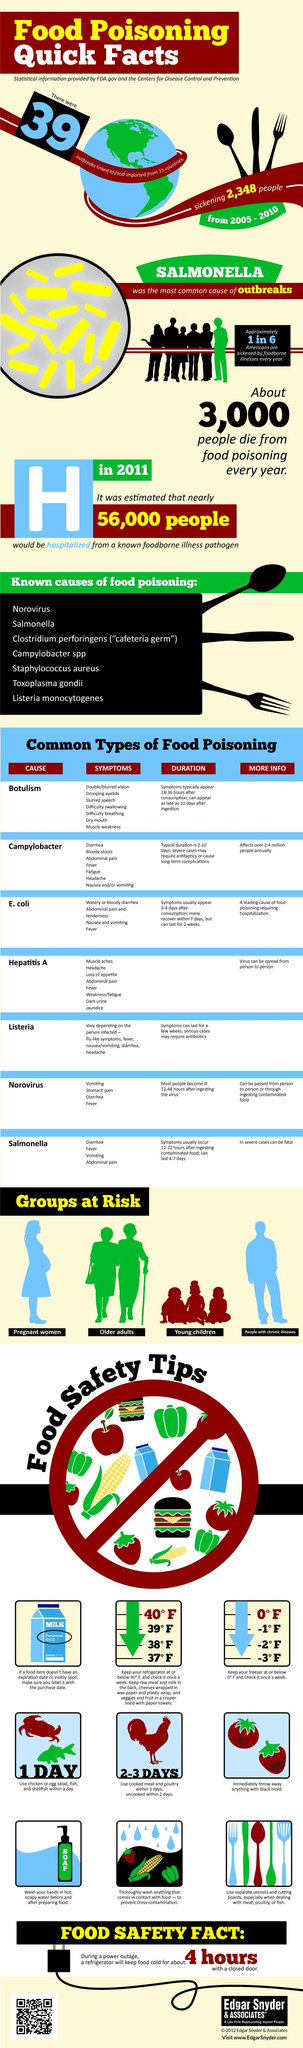Besides old adults and young children, which groups are at risk of food poisoning?
Answer the question with a short phrase. pregnant women, people with chronic illnesses What is listed second among the known causes of food poisoning? Salmonella In which type of food poisoning flu-like symptoms can be present? Listeria What type of food poisoning can be fatal in severe cases? Salmonella Drooping eyelids are a symptom in which type of food poisoning? Botulism Age-wise which categories of people are at risk in case of food poisoning? Older adults, young children Which virus can be passed from person to person or through ingesting contaminated food? Norovirus Jaundice is a symptom in which type of food poisoning? Hepatitis A What affects over 2.4 million people annually? Campylobacter What is a leading cause of food poisoning requiring hospitalization? E. coli 